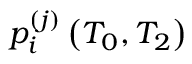Convert formula to latex. <formula><loc_0><loc_0><loc_500><loc_500>p _ { i } ^ { ( j ) } \left ( T _ { 0 } , T _ { 2 } \right )</formula> 